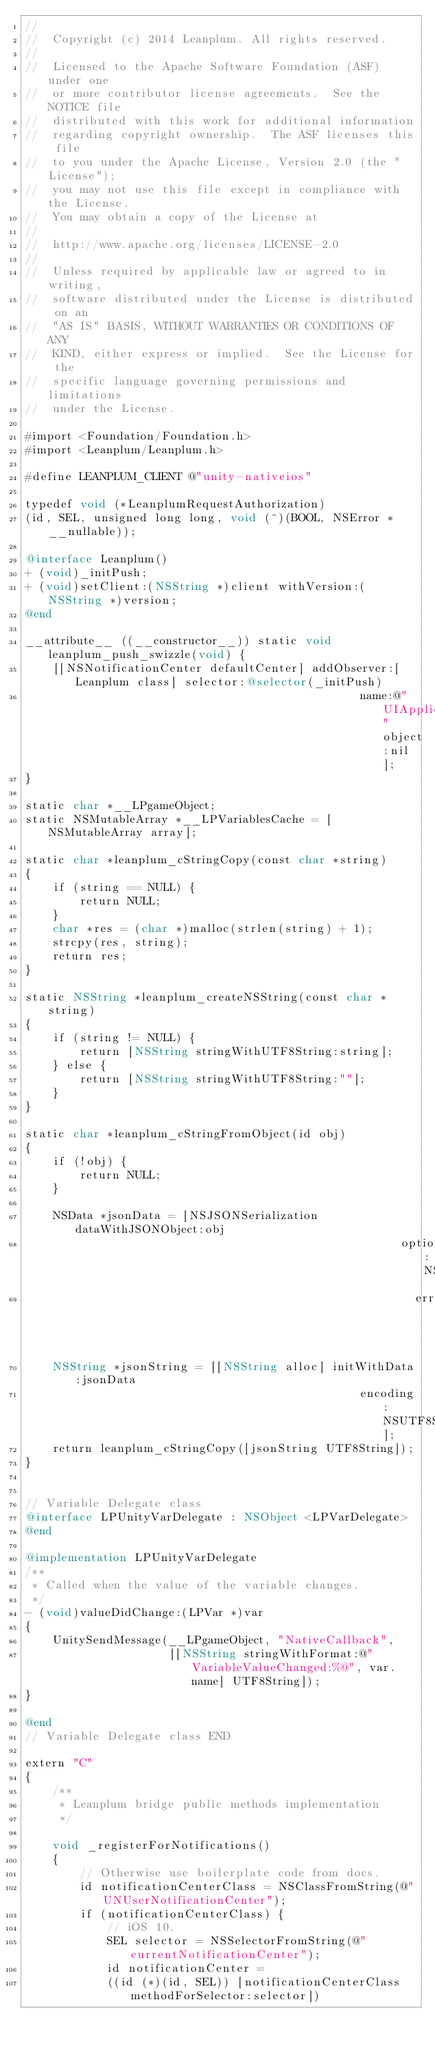Convert code to text. <code><loc_0><loc_0><loc_500><loc_500><_ObjectiveC_>//
//  Copyright (c) 2014 Leanplum. All rights reserved.
//
//  Licensed to the Apache Software Foundation (ASF) under one
//  or more contributor license agreements.  See the NOTICE file
//  distributed with this work for additional information
//  regarding copyright ownership.  The ASF licenses this file
//  to you under the Apache License, Version 2.0 (the "License");
//  you may not use this file except in compliance with the License.
//  You may obtain a copy of the License at
//
//  http://www.apache.org/licenses/LICENSE-2.0
//
//  Unless required by applicable law or agreed to in writing,
//  software distributed under the License is distributed on an
//  "AS IS" BASIS, WITHOUT WARRANTIES OR CONDITIONS OF ANY
//  KIND, either express or implied.  See the License for the
//  specific language governing permissions and limitations
//  under the License.

#import <Foundation/Foundation.h>
#import <Leanplum/Leanplum.h>

#define LEANPLUM_CLIENT @"unity-nativeios"

typedef void (*LeanplumRequestAuthorization)
(id, SEL, unsigned long long, void (^)(BOOL, NSError *__nullable));

@interface Leanplum()
+ (void)_initPush;
+ (void)setClient:(NSString *)client withVersion:(NSString *)version;
@end

__attribute__ ((__constructor__)) static void leanplum_push_swizzle(void) {
    [[NSNotificationCenter defaultCenter] addObserver:[Leanplum class] selector:@selector(_initPush)
                                                 name:@"UIApplicationDidFinishLaunchingNotification" object:nil];
}

static char *__LPgameObject;
static NSMutableArray *__LPVariablesCache = [NSMutableArray array];

static char *leanplum_cStringCopy(const char *string)
{
    if (string == NULL) {
        return NULL;
    }
    char *res = (char *)malloc(strlen(string) + 1);
    strcpy(res, string);
    return res;
}

static NSString *leanplum_createNSString(const char *string)
{
    if (string != NULL) {
        return [NSString stringWithUTF8String:string];
    } else {
        return [NSString stringWithUTF8String:""];
    }
}

static char *leanplum_cStringFromObject(id obj)
{
    if (!obj) {
        return NULL;
    }

    NSData *jsonData = [NSJSONSerialization dataWithJSONObject:obj
                                                       options:NSUTF8StringEncoding
                                                         error:nil];
    NSString *jsonString = [[NSString alloc] initWithData:jsonData
                                                 encoding:NSUTF8StringEncoding];
    return leanplum_cStringCopy([jsonString UTF8String]);
}


// Variable Delegate class
@interface LPUnityVarDelegate : NSObject <LPVarDelegate>
@end

@implementation LPUnityVarDelegate
/**
 * Called when the value of the variable changes.
 */
- (void)valueDidChange:(LPVar *)var
{
    UnitySendMessage(__LPgameObject, "NativeCallback",
                     [[NSString stringWithFormat:@"VariableValueChanged:%@", var.name] UTF8String]);
}

@end
// Variable Delegate class END

extern "C"
{
    /**
     * Leanplum bridge public methods implementation
     */

    void _registerForNotifications()
    {
        // Otherwise use boilerplate code from docs.
        id notificationCenterClass = NSClassFromString(@"UNUserNotificationCenter");
        if (notificationCenterClass) {
            // iOS 10.
            SEL selector = NSSelectorFromString(@"currentNotificationCenter");
            id notificationCenter =
            ((id (*)(id, SEL)) [notificationCenterClass methodForSelector:selector])</code> 